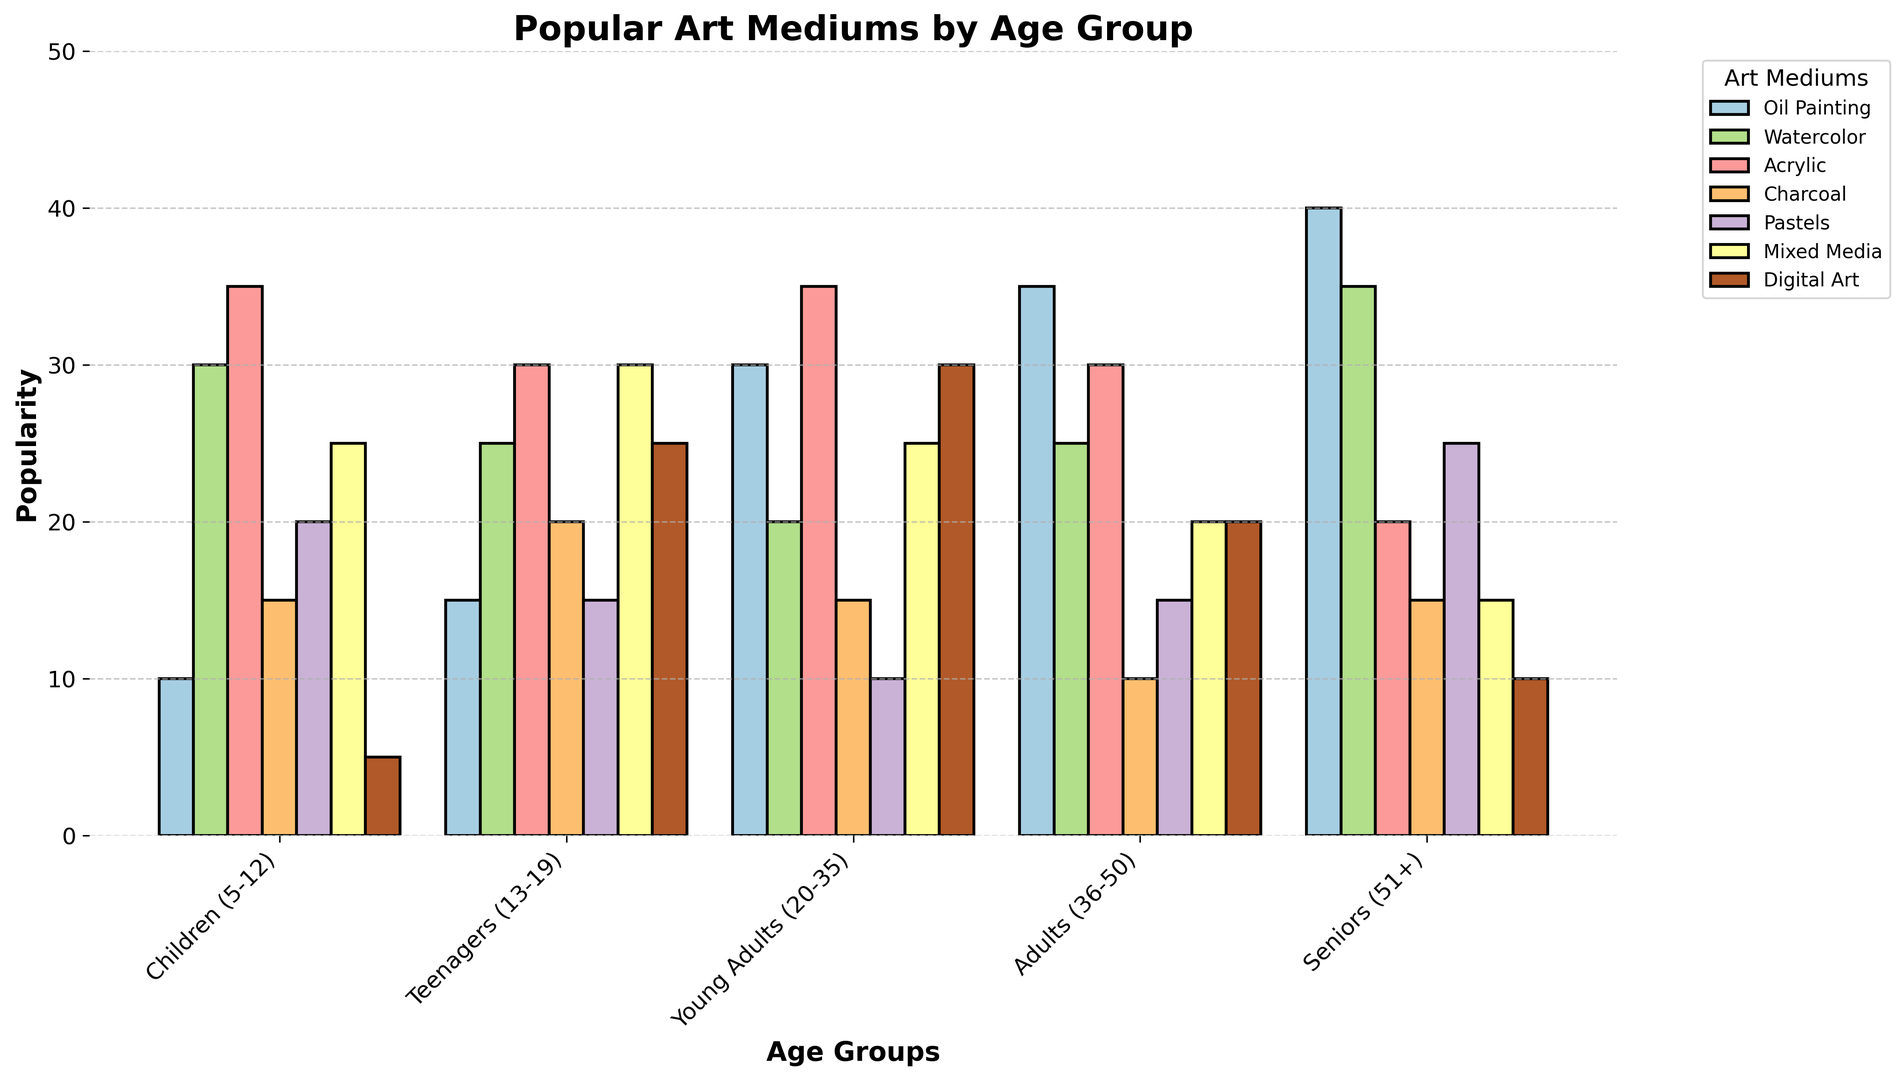Which age group has the highest popularity for Oil Painting? To find the age group with the highest popularity for Oil Painting, we look at the Oil Painting bar across all age groups. Seniors (51+) has the highest bar at 40.
Answer: Seniors (51+) Which art medium is least popular among Young Adults (20-35)? To determine the least popular art medium among Young Adults, compare the height of all bars representing different art mediums in the Young Adults category. Pastels has the lowest value at 10.
Answer: Pastels What is the average popularity of Watercolor across all age groups? To calculate the average popularity of Watercolor, sum the values for all age groups (30 + 25 + 20 + 25 + 35) and divide by the number of age groups, which is 5. The sum is 135, so the average is 135/5 = 27.
Answer: 27 Which age group has a higher popularity for Digital Art, Teenagers (13-19) or Young Adults (20-35)? Look at the bars for Digital Art in both age groups. Teenagers have a value of 25, while Young Adults have 30. Thus, Young Adults have a higher value.
Answer: Young Adults (20-35) Which age group has the lowest popularity for Charcoal? To identify the age group with the lowest popularity for Charcoal, compare the heights of the Charcoal bars in each age group. The Adults (36-50) category has the lowest Charcoal value at 10.
Answer: Adults (36-50) What is the total popularity for Acrylic across all age groups? Add the values of Acrylic for all age groups: (35 + 30 + 35 + 30 + 20). The sum of these values is 150.
Answer: 150 How does the popularity of Mixed Media for Children (5-12) compare to that for Seniors (51+)? Compare the heights of the bars for Mixed Media in the Children and Seniors age groups. Children have a value of 25, whereas Seniors have 15, so Mixed Media is more popular among children.
Answer: Children (5-12) Which age group has the most balanced popularity across all art mediums, based on bar heights? To find the most balanced age group, look at the age group where the height difference across all bars is minimal. Young Adults appear to have more balanced bar heights across all art mediums.
Answer: Young Adults (20-35) How much more popular is Watercolor than Acrylic among Teenagers (13-19)? Subtract the popularity of Acrylic (30) from Watercolor (25) among Teenagers. The difference is 25 - 30 = -5, so Acrylic is more popular by 5 units, indicating Watercolor is 5 less popular.
Answer: 5 less popular What is the combined popularity of Pastels and Digital Art for Adults (36-50)? Add the values for Pastels (15) and Digital Art (20) in the Adults age group. The combined popularity is 15 + 20 = 35.
Answer: 35 